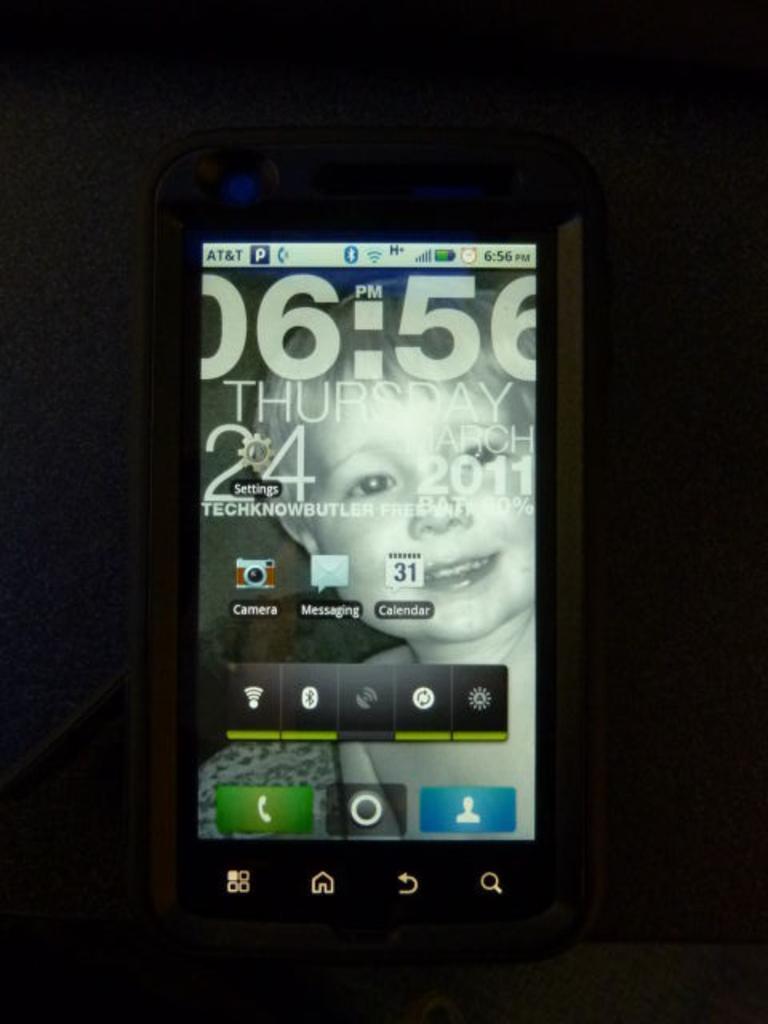Describe this image in one or two sentences. In the center of the image we can see a mobile. 